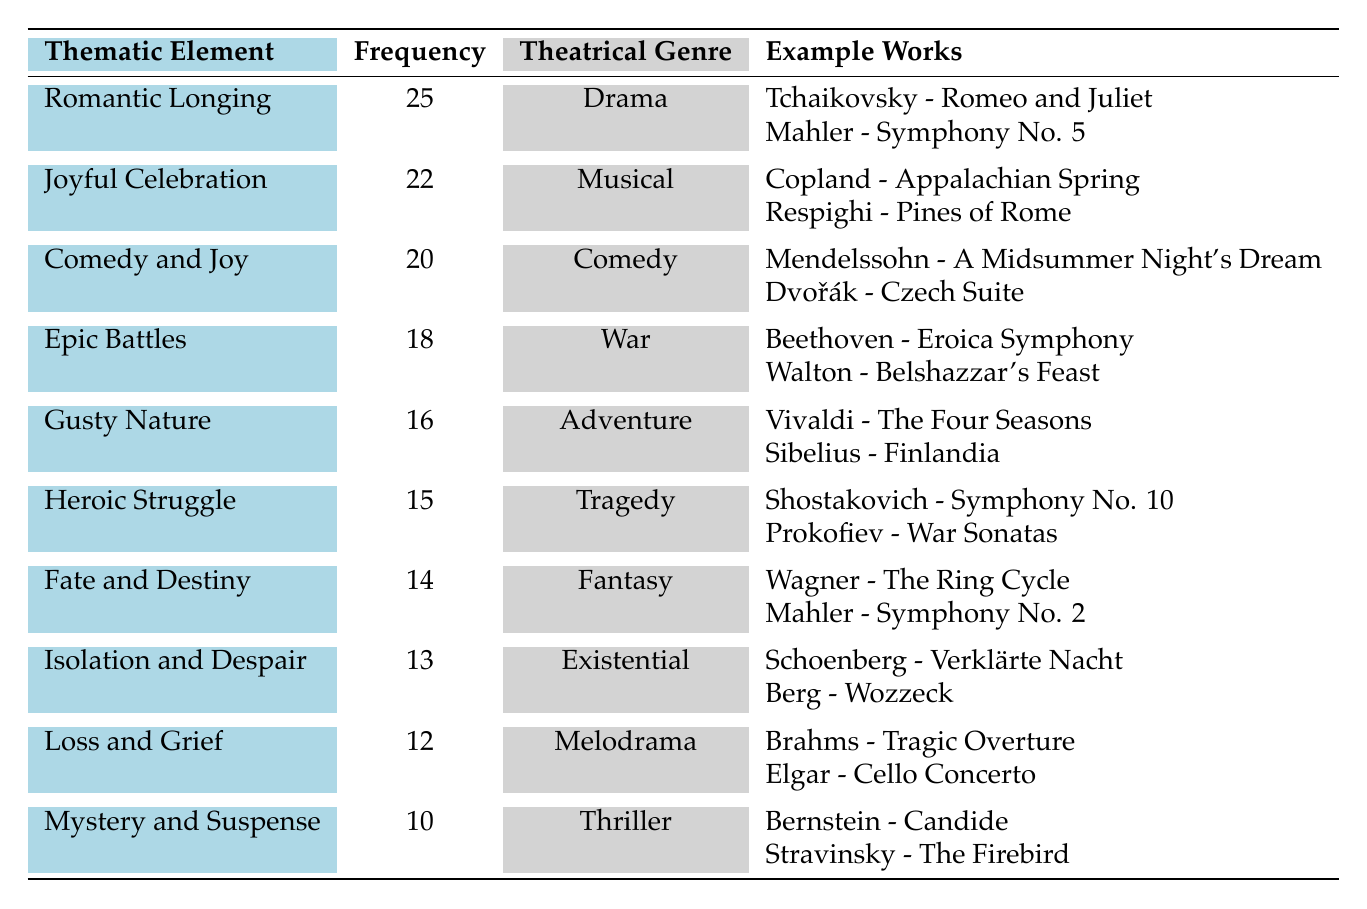What is the frequency of the thematic element "Romantic Longing"? The table shows that the frequency of "Romantic Longing" is 25.
Answer: 25 Which thematic element has the highest frequency? According to the table, "Romantic Longing" has the highest frequency at 25.
Answer: Romantic Longing How many thematic elements are related to the genre "Comedy"? The table lists one thematic element related to "Comedy," which is "Comedy and Joy."
Answer: 1 What is the average frequency of the thematic elements associated with "Melodrama" and "Thriller"? The frequencies for "Melodrama" (12) and "Thriller" (10) are summed to 22, then divided by 2 (22/2) equals 11.
Answer: 11 Is there a thematic element related to "Adventure" that has a higher frequency than 15? The table indicates that "Gusty Nature" (16) is related to "Adventure" and has a frequency higher than 15.
Answer: Yes Which thematic element related to "War" has a frequency of 18? The thematic element "Epic Battles" corresponds to the genre "War" and has a frequency of 18.
Answer: Epic Battles How does the frequency of "Isolation and Despair" compare to the frequency of "Loss and Grief"? The frequency for "Isolation and Despair" is 13, while "Loss and Grief" is 12, indicating that "Isolation and Despair" has a higher frequency.
Answer: Isolation and Despair What is the total frequency of thematic elements for "Drama" and "War"? "Romantic Longing" frequency for "Drama" is 25, and "Epic Battles" for "War" is 18. Summing these gives 25 + 18 = 43.
Answer: 43 Which thematic element is associated with "Fantasy" and what is its frequency? The thematic element "Fate and Destiny" is associated with "Fantasy" and has a frequency of 14.
Answer: Fate and Destiny, 14 Does "Gusty Nature" have a higher frequency than "Heroic Struggle"? The frequency for "Gusty Nature" is 16 and for "Heroic Struggle" is 15, indicating that "Gusty Nature" has a higher frequency.
Answer: Yes How many thematic elements have a frequency of 15 or more? Counting thematic elements with frequencies of 15 or above: "Romantic Longing" (25), "Joyful Celebration" (22), "Comedy and Joy" (20), "Epic Battles" (18), "Gusty Nature" (16), "Heroic Struggle" (15) gives a total of 6.
Answer: 6 